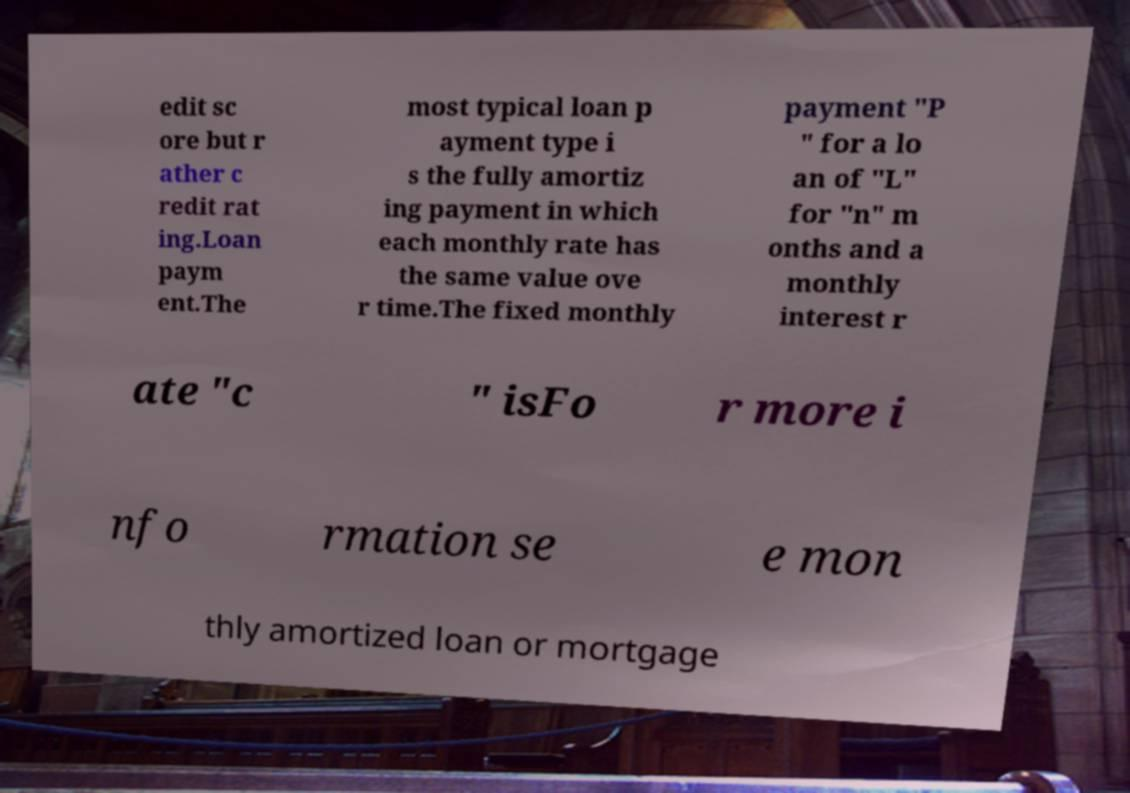Please read and relay the text visible in this image. What does it say? edit sc ore but r ather c redit rat ing.Loan paym ent.The most typical loan p ayment type i s the fully amortiz ing payment in which each monthly rate has the same value ove r time.The fixed monthly payment "P " for a lo an of "L" for "n" m onths and a monthly interest r ate "c " isFo r more i nfo rmation se e mon thly amortized loan or mortgage 